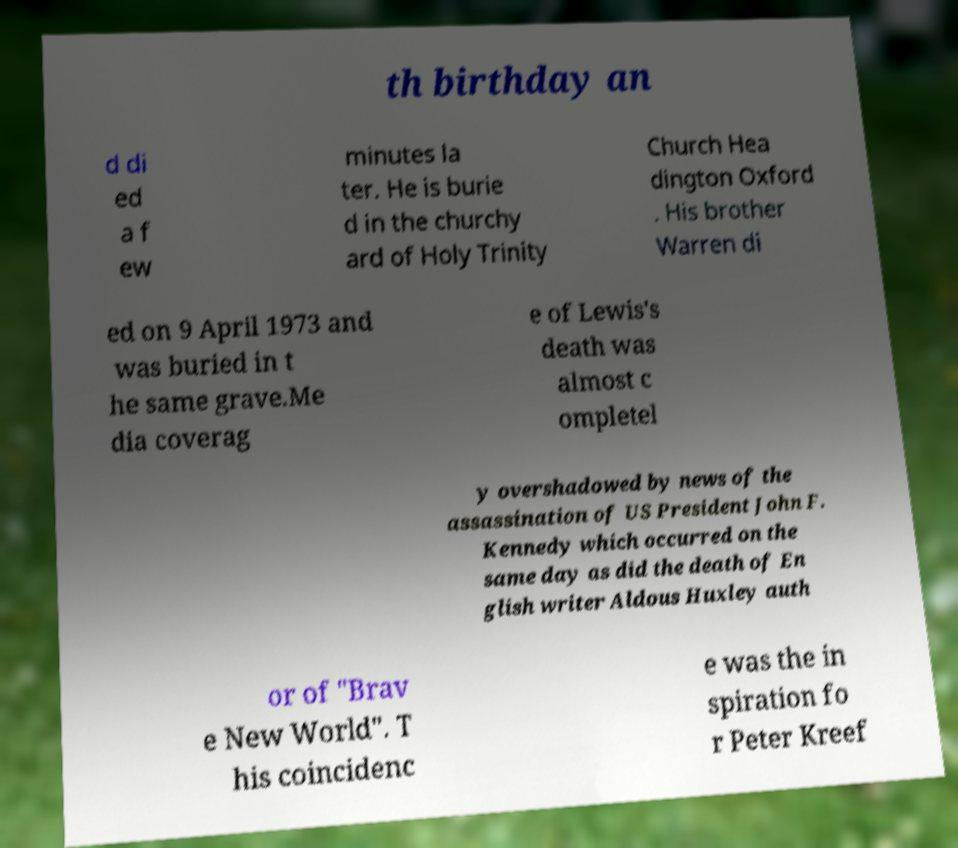There's text embedded in this image that I need extracted. Can you transcribe it verbatim? th birthday an d di ed a f ew minutes la ter. He is burie d in the churchy ard of Holy Trinity Church Hea dington Oxford . His brother Warren di ed on 9 April 1973 and was buried in t he same grave.Me dia coverag e of Lewis's death was almost c ompletel y overshadowed by news of the assassination of US President John F. Kennedy which occurred on the same day as did the death of En glish writer Aldous Huxley auth or of "Brav e New World". T his coincidenc e was the in spiration fo r Peter Kreef 